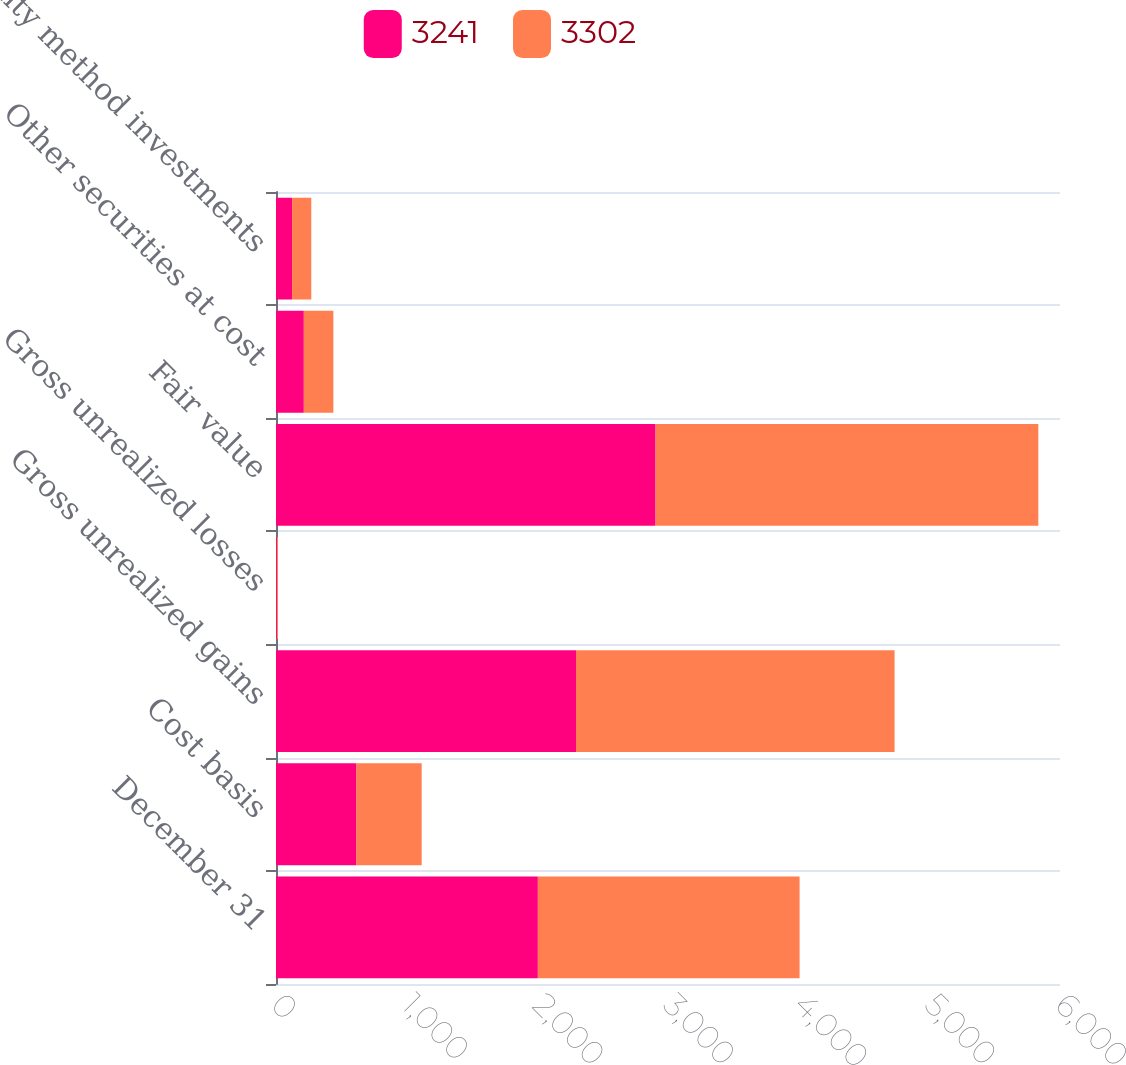Convert chart to OTSL. <chart><loc_0><loc_0><loc_500><loc_500><stacked_bar_chart><ecel><fcel>December 31<fcel>Cost basis<fcel>Gross unrealized gains<fcel>Gross unrealized losses<fcel>Fair value<fcel>Other securities at cost<fcel>Equity method investments<nl><fcel>3241<fcel>2004<fcel>616<fcel>2296<fcel>7<fcel>2905<fcel>213<fcel>123<nl><fcel>3302<fcel>2003<fcel>499<fcel>2438<fcel>8<fcel>2929<fcel>226<fcel>147<nl></chart> 